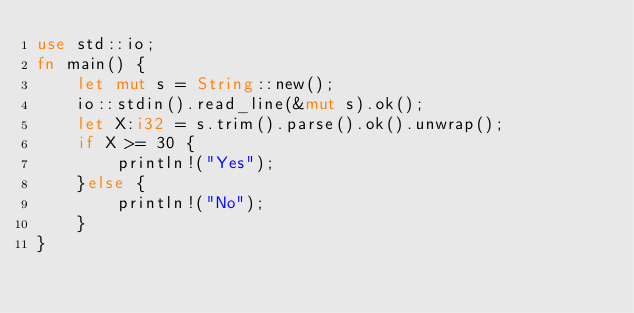Convert code to text. <code><loc_0><loc_0><loc_500><loc_500><_Rust_>use std::io;
fn main() {
    let mut s = String::new();
    io::stdin().read_line(&mut s).ok();
    let X:i32 = s.trim().parse().ok().unwrap();
    if X >= 30 {
        println!("Yes");
    }else {
        println!("No");
    }
}
</code> 